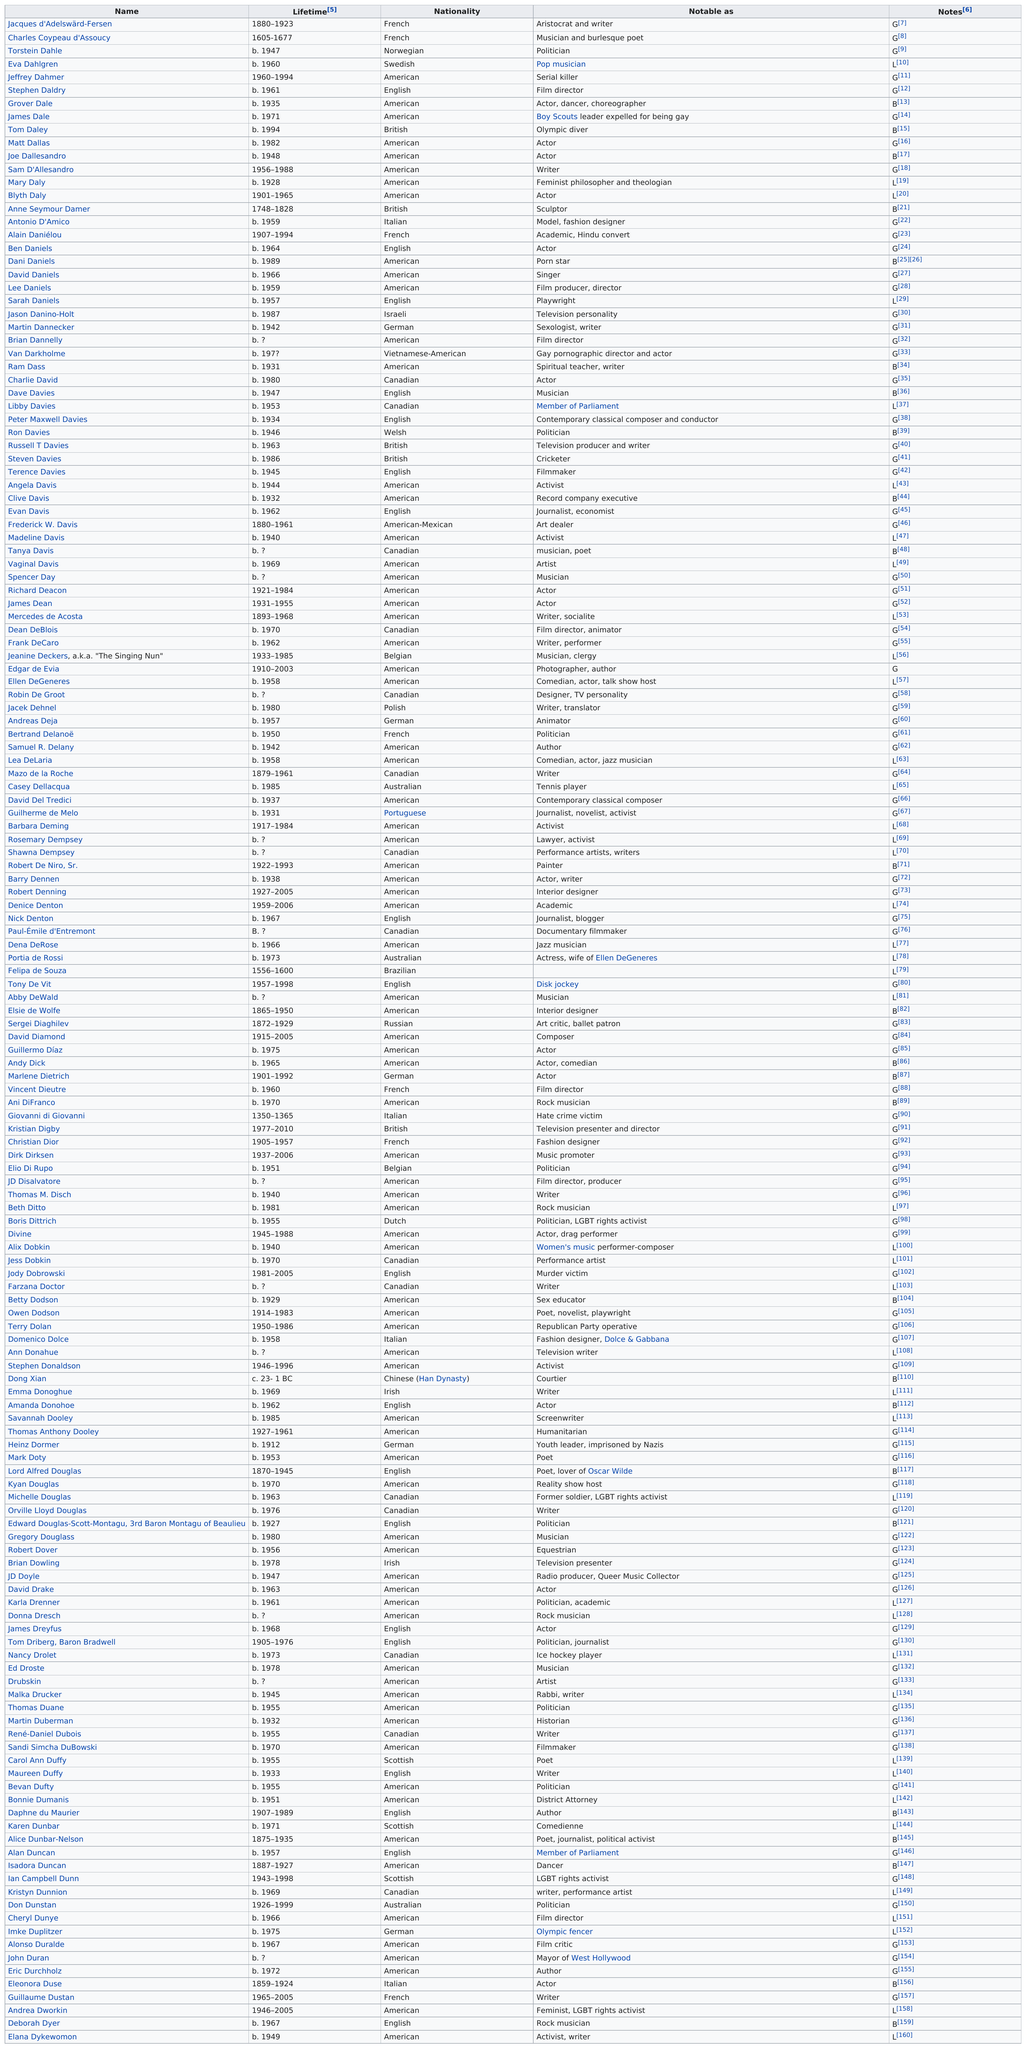Indicate a few pertinent items in this graphic. Elana Dykewomon's name is listed last. The country that is most heavily represented on this list is America. Grover Dale, a person on the list from the United States, was born at least 60 years ago. Elana Dykewomon is the last living person on the list. Matt Dallas was previously known by the name Tom Daley. 